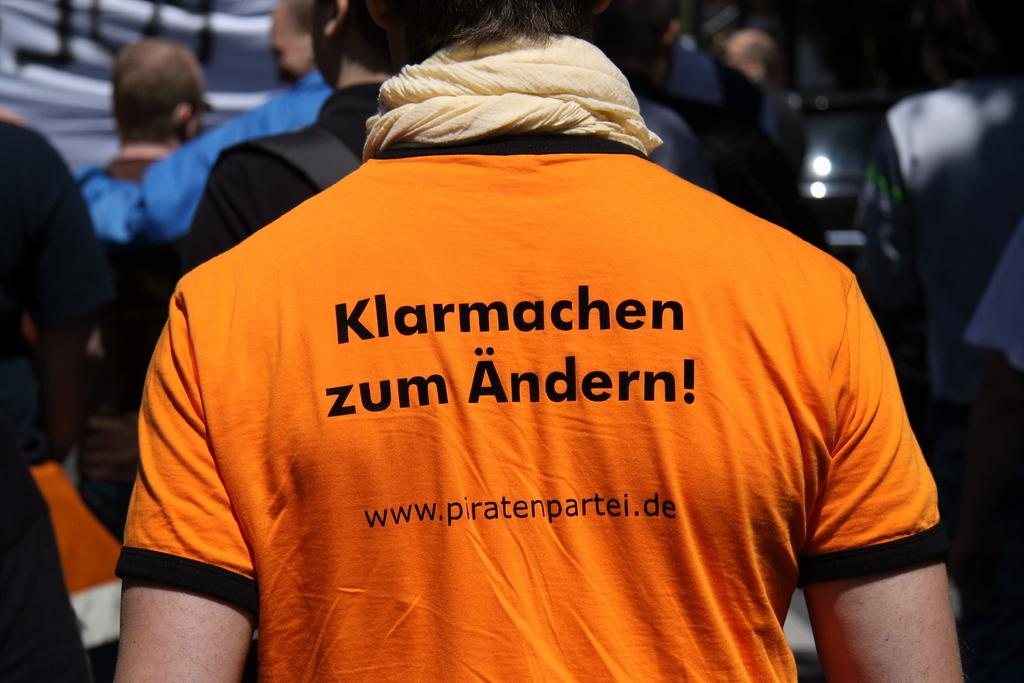<image>
Offer a succinct explanation of the picture presented. A man wearing an orange shirt with the letter w on it. 